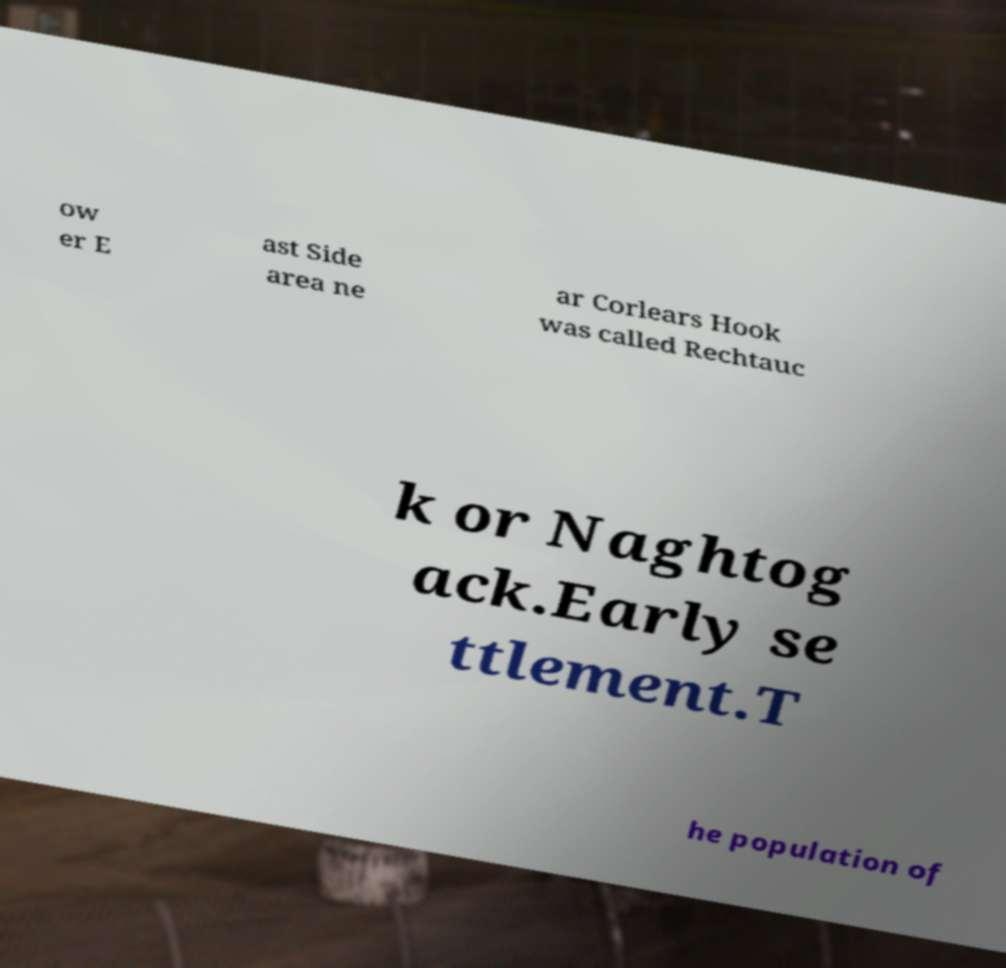Please read and relay the text visible in this image. What does it say? ow er E ast Side area ne ar Corlears Hook was called Rechtauc k or Naghtog ack.Early se ttlement.T he population of 